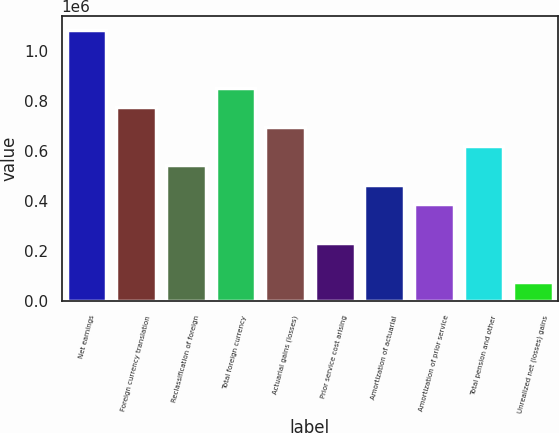Convert chart to OTSL. <chart><loc_0><loc_0><loc_500><loc_500><bar_chart><fcel>Net earnings<fcel>Foreign currency translation<fcel>Reclassification of foreign<fcel>Total foreign currency<fcel>Actuarial gains (losses)<fcel>Prior service cost arising<fcel>Amortization of actuarial<fcel>Amortization of prior service<fcel>Total pension and other<fcel>Unrealized net (losses) gains<nl><fcel>1.08529e+06<fcel>775235<fcel>542697<fcel>852748<fcel>697722<fcel>232645<fcel>465184<fcel>387671<fcel>620209<fcel>77619.8<nl></chart> 